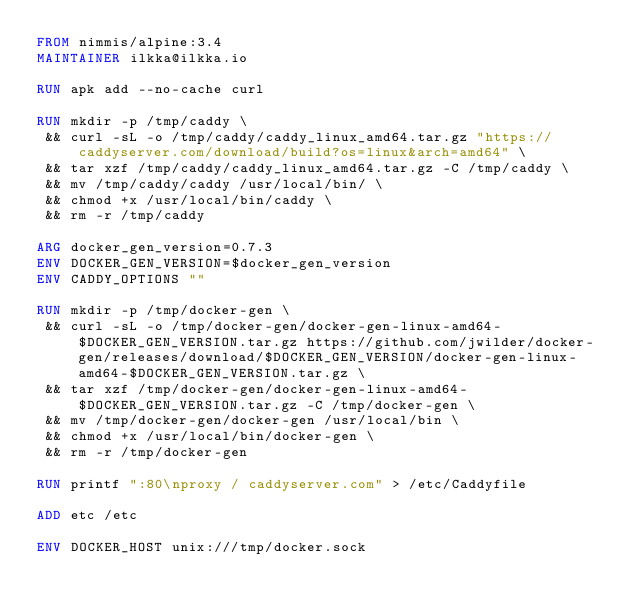<code> <loc_0><loc_0><loc_500><loc_500><_Dockerfile_>FROM nimmis/alpine:3.4
MAINTAINER ilkka@ilkka.io

RUN apk add --no-cache curl

RUN mkdir -p /tmp/caddy \
 && curl -sL -o /tmp/caddy/caddy_linux_amd64.tar.gz "https://caddyserver.com/download/build?os=linux&arch=amd64" \
 && tar xzf /tmp/caddy/caddy_linux_amd64.tar.gz -C /tmp/caddy \
 && mv /tmp/caddy/caddy /usr/local/bin/ \
 && chmod +x /usr/local/bin/caddy \
 && rm -r /tmp/caddy

ARG docker_gen_version=0.7.3
ENV DOCKER_GEN_VERSION=$docker_gen_version
ENV CADDY_OPTIONS ""

RUN mkdir -p /tmp/docker-gen \
 && curl -sL -o /tmp/docker-gen/docker-gen-linux-amd64-$DOCKER_GEN_VERSION.tar.gz https://github.com/jwilder/docker-gen/releases/download/$DOCKER_GEN_VERSION/docker-gen-linux-amd64-$DOCKER_GEN_VERSION.tar.gz \
 && tar xzf /tmp/docker-gen/docker-gen-linux-amd64-$DOCKER_GEN_VERSION.tar.gz -C /tmp/docker-gen \
 && mv /tmp/docker-gen/docker-gen /usr/local/bin \
 && chmod +x /usr/local/bin/docker-gen \
 && rm -r /tmp/docker-gen

RUN printf ":80\nproxy / caddyserver.com" > /etc/Caddyfile

ADD etc /etc

ENV DOCKER_HOST unix:///tmp/docker.sock
</code> 